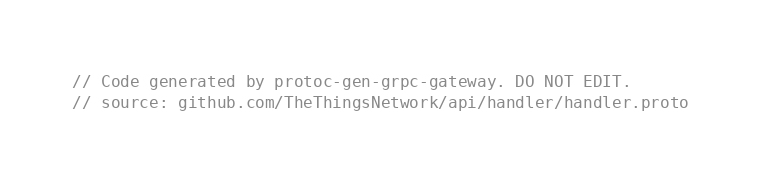Convert code to text. <code><loc_0><loc_0><loc_500><loc_500><_Go_>// Code generated by protoc-gen-grpc-gateway. DO NOT EDIT.
// source: github.com/TheThingsNetwork/api/handler/handler.proto
</code> 